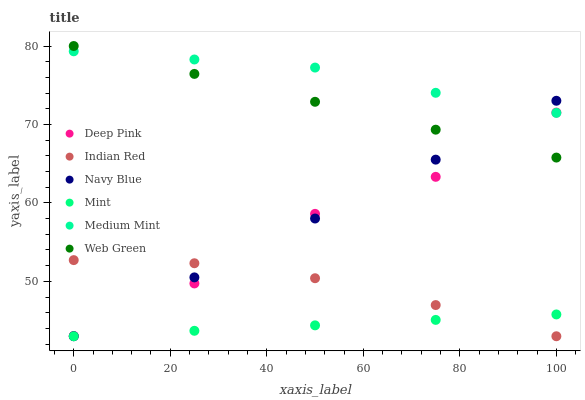Does Mint have the minimum area under the curve?
Answer yes or no. Yes. Does Medium Mint have the maximum area under the curve?
Answer yes or no. Yes. Does Deep Pink have the minimum area under the curve?
Answer yes or no. No. Does Deep Pink have the maximum area under the curve?
Answer yes or no. No. Is Mint the smoothest?
Answer yes or no. Yes. Is Deep Pink the roughest?
Answer yes or no. Yes. Is Navy Blue the smoothest?
Answer yes or no. No. Is Navy Blue the roughest?
Answer yes or no. No. Does Navy Blue have the lowest value?
Answer yes or no. Yes. Does Deep Pink have the lowest value?
Answer yes or no. No. Does Web Green have the highest value?
Answer yes or no. Yes. Does Deep Pink have the highest value?
Answer yes or no. No. Is Mint less than Medium Mint?
Answer yes or no. Yes. Is Medium Mint greater than Mint?
Answer yes or no. Yes. Does Indian Red intersect Navy Blue?
Answer yes or no. Yes. Is Indian Red less than Navy Blue?
Answer yes or no. No. Is Indian Red greater than Navy Blue?
Answer yes or no. No. Does Mint intersect Medium Mint?
Answer yes or no. No. 